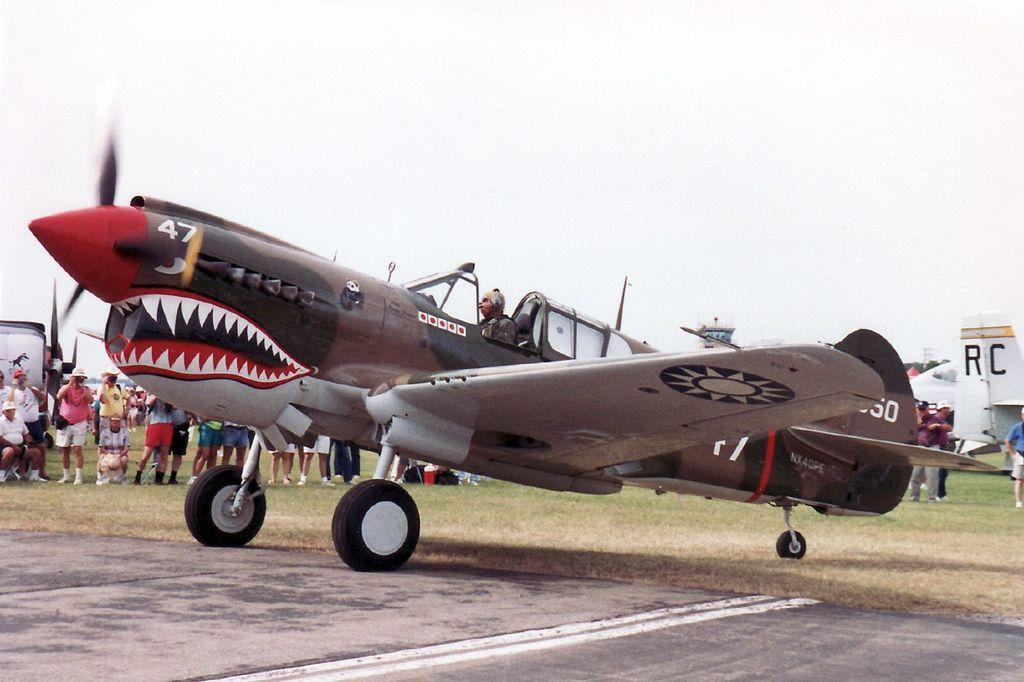What is the main subject of the image? The main subject of the image is an airplane. Where is the airplane located in the image? The airplane is on the ground in the image. What can be seen in the background of the image? The sky is visible in the background of the image. What else is present in the image besides the airplane? There is a runway and people standing on the ground in the image. What type of song can be heard playing from the airplane in the image? There is no indication in the image that a song is playing from the airplane, so it cannot be determined from the picture. 